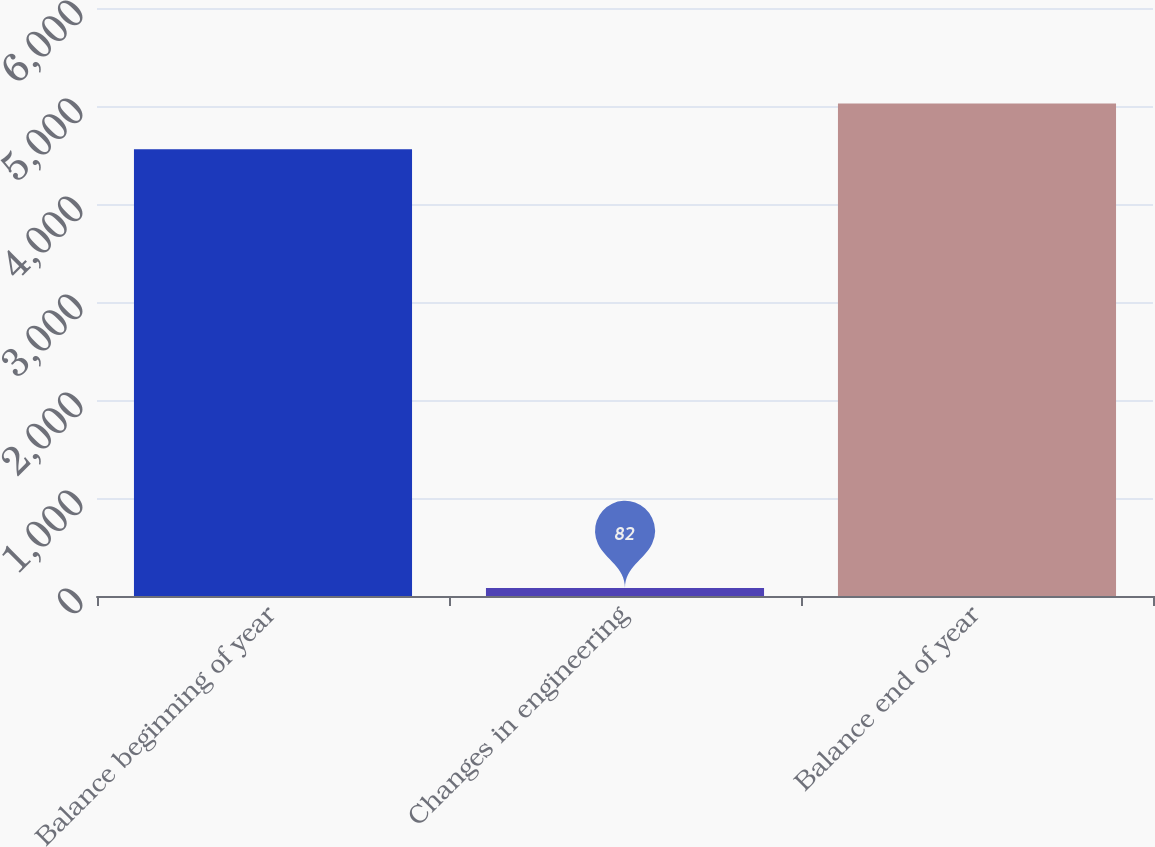Convert chart. <chart><loc_0><loc_0><loc_500><loc_500><bar_chart><fcel>Balance beginning of year<fcel>Changes in engineering<fcel>Balance end of year<nl><fcel>4558<fcel>82<fcel>5026.7<nl></chart> 